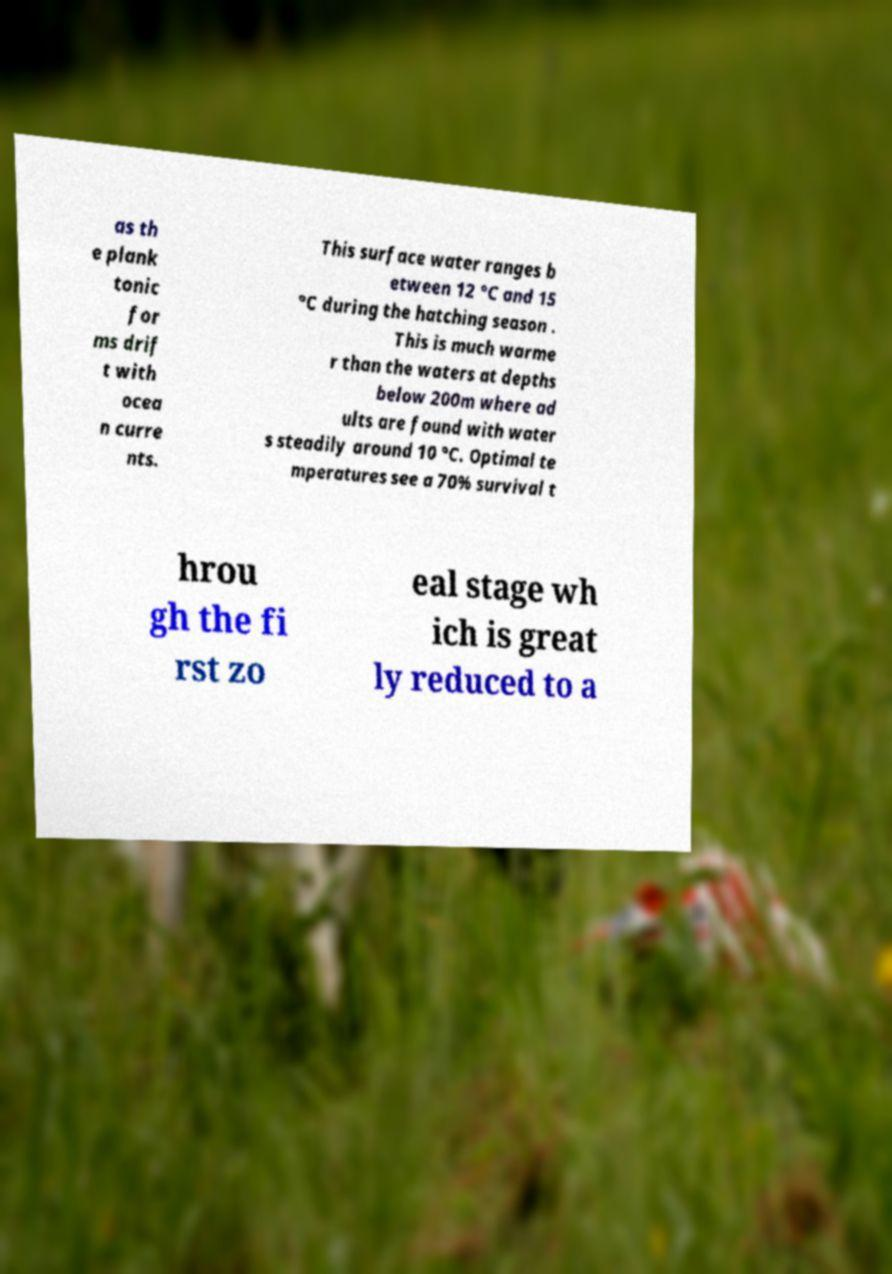There's text embedded in this image that I need extracted. Can you transcribe it verbatim? as th e plank tonic for ms drif t with ocea n curre nts. This surface water ranges b etween 12 °C and 15 °C during the hatching season . This is much warme r than the waters at depths below 200m where ad ults are found with water s steadily around 10 °C. Optimal te mperatures see a 70% survival t hrou gh the fi rst zo eal stage wh ich is great ly reduced to a 